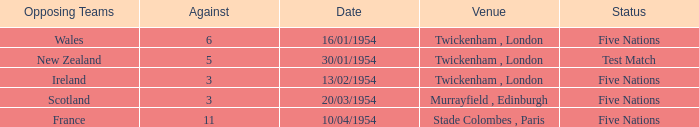What is the lowest against for games played in the stade colombes, paris venue? 11.0. 